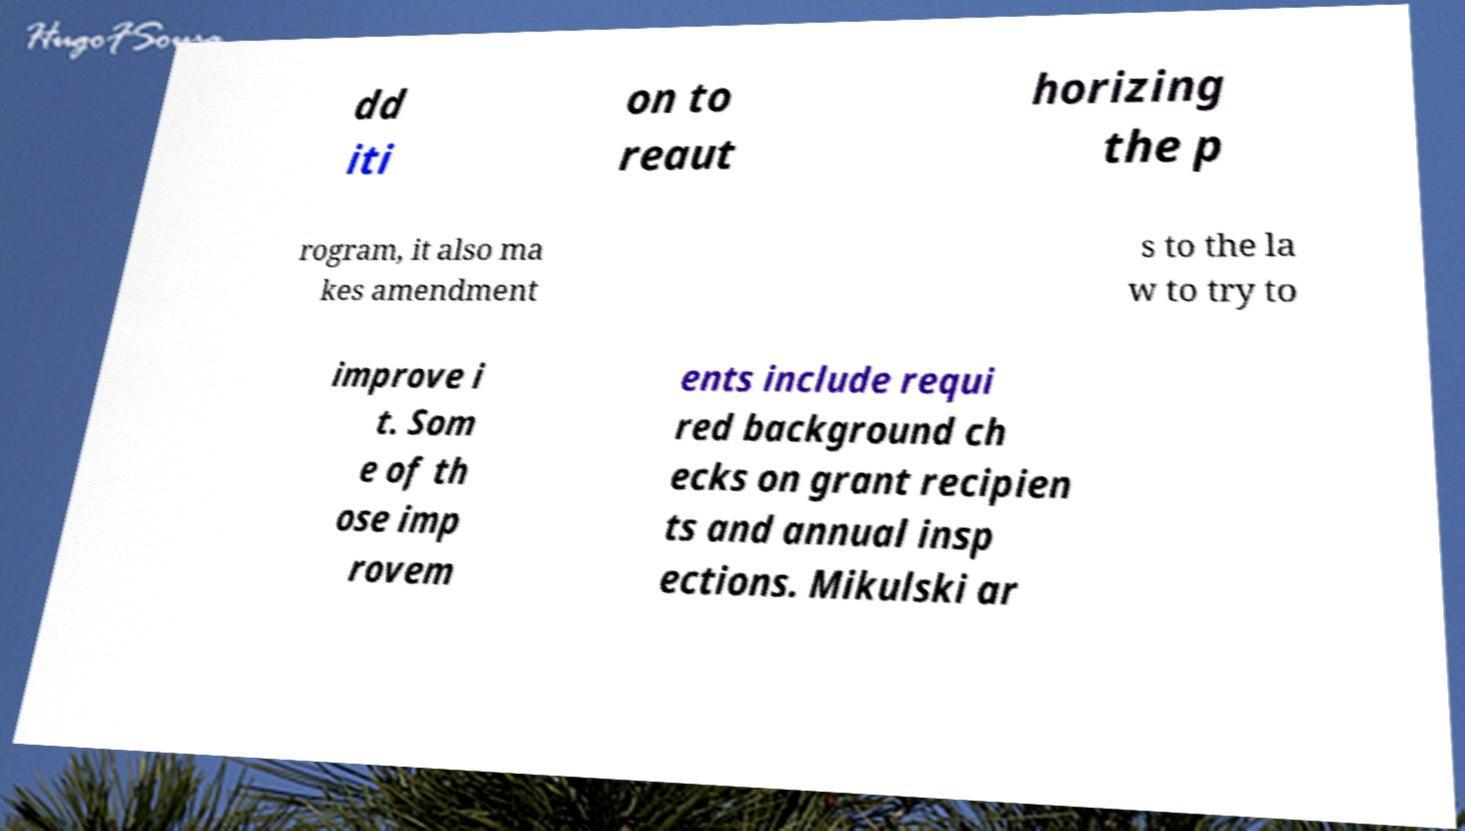Can you accurately transcribe the text from the provided image for me? dd iti on to reaut horizing the p rogram, it also ma kes amendment s to the la w to try to improve i t. Som e of th ose imp rovem ents include requi red background ch ecks on grant recipien ts and annual insp ections. Mikulski ar 